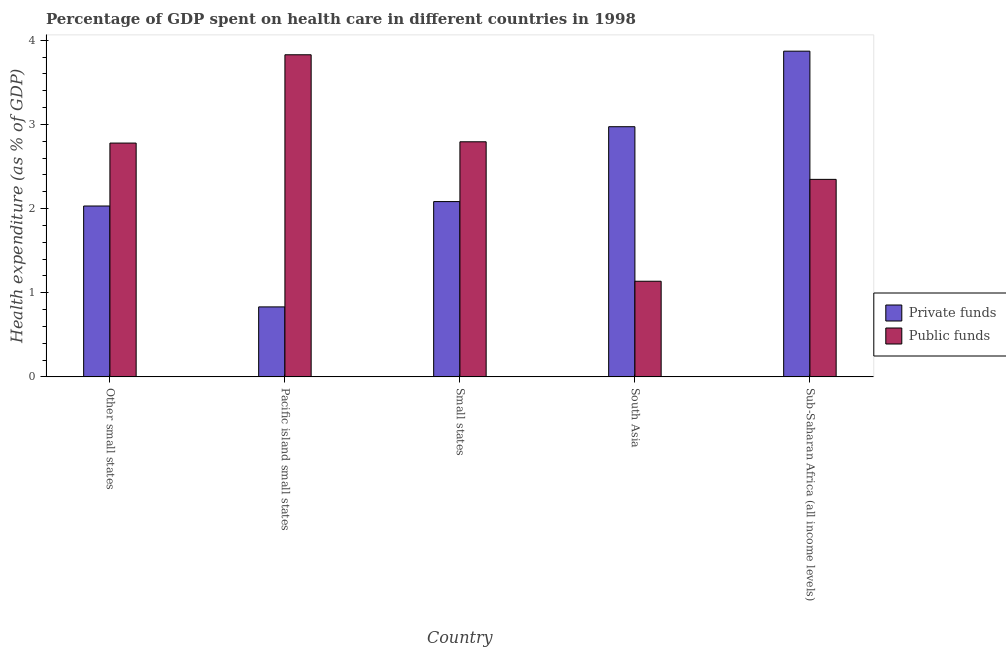How many groups of bars are there?
Provide a succinct answer. 5. Are the number of bars per tick equal to the number of legend labels?
Give a very brief answer. Yes. Are the number of bars on each tick of the X-axis equal?
Ensure brevity in your answer.  Yes. How many bars are there on the 3rd tick from the right?
Your response must be concise. 2. What is the amount of private funds spent in healthcare in South Asia?
Your answer should be compact. 2.97. Across all countries, what is the maximum amount of private funds spent in healthcare?
Offer a terse response. 3.87. Across all countries, what is the minimum amount of private funds spent in healthcare?
Ensure brevity in your answer.  0.83. In which country was the amount of public funds spent in healthcare maximum?
Give a very brief answer. Pacific island small states. In which country was the amount of public funds spent in healthcare minimum?
Offer a terse response. South Asia. What is the total amount of private funds spent in healthcare in the graph?
Make the answer very short. 11.79. What is the difference between the amount of private funds spent in healthcare in Small states and that in Sub-Saharan Africa (all income levels)?
Your response must be concise. -1.79. What is the difference between the amount of public funds spent in healthcare in Pacific island small states and the amount of private funds spent in healthcare in Other small states?
Keep it short and to the point. 1.8. What is the average amount of private funds spent in healthcare per country?
Offer a very short reply. 2.36. What is the difference between the amount of public funds spent in healthcare and amount of private funds spent in healthcare in Pacific island small states?
Offer a very short reply. 3. In how many countries, is the amount of private funds spent in healthcare greater than 3.2 %?
Make the answer very short. 1. What is the ratio of the amount of public funds spent in healthcare in Small states to that in Sub-Saharan Africa (all income levels)?
Provide a succinct answer. 1.19. Is the difference between the amount of public funds spent in healthcare in Other small states and Pacific island small states greater than the difference between the amount of private funds spent in healthcare in Other small states and Pacific island small states?
Offer a very short reply. No. What is the difference between the highest and the second highest amount of private funds spent in healthcare?
Keep it short and to the point. 0.9. What is the difference between the highest and the lowest amount of public funds spent in healthcare?
Make the answer very short. 2.69. Is the sum of the amount of public funds spent in healthcare in South Asia and Sub-Saharan Africa (all income levels) greater than the maximum amount of private funds spent in healthcare across all countries?
Ensure brevity in your answer.  No. What does the 1st bar from the left in South Asia represents?
Keep it short and to the point. Private funds. What does the 2nd bar from the right in Pacific island small states represents?
Ensure brevity in your answer.  Private funds. How many bars are there?
Keep it short and to the point. 10. How many countries are there in the graph?
Make the answer very short. 5. What is the difference between two consecutive major ticks on the Y-axis?
Your answer should be very brief. 1. Does the graph contain any zero values?
Provide a succinct answer. No. Does the graph contain grids?
Provide a succinct answer. No. How many legend labels are there?
Keep it short and to the point. 2. What is the title of the graph?
Offer a very short reply. Percentage of GDP spent on health care in different countries in 1998. Does "Residents" appear as one of the legend labels in the graph?
Ensure brevity in your answer.  No. What is the label or title of the Y-axis?
Offer a terse response. Health expenditure (as % of GDP). What is the Health expenditure (as % of GDP) in Private funds in Other small states?
Make the answer very short. 2.03. What is the Health expenditure (as % of GDP) in Public funds in Other small states?
Provide a short and direct response. 2.78. What is the Health expenditure (as % of GDP) in Private funds in Pacific island small states?
Your response must be concise. 0.83. What is the Health expenditure (as % of GDP) in Public funds in Pacific island small states?
Offer a very short reply. 3.83. What is the Health expenditure (as % of GDP) of Private funds in Small states?
Offer a very short reply. 2.08. What is the Health expenditure (as % of GDP) of Public funds in Small states?
Your answer should be compact. 2.79. What is the Health expenditure (as % of GDP) of Private funds in South Asia?
Make the answer very short. 2.97. What is the Health expenditure (as % of GDP) of Public funds in South Asia?
Offer a very short reply. 1.14. What is the Health expenditure (as % of GDP) of Private funds in Sub-Saharan Africa (all income levels)?
Offer a terse response. 3.87. What is the Health expenditure (as % of GDP) in Public funds in Sub-Saharan Africa (all income levels)?
Offer a very short reply. 2.35. Across all countries, what is the maximum Health expenditure (as % of GDP) of Private funds?
Give a very brief answer. 3.87. Across all countries, what is the maximum Health expenditure (as % of GDP) of Public funds?
Give a very brief answer. 3.83. Across all countries, what is the minimum Health expenditure (as % of GDP) of Private funds?
Provide a short and direct response. 0.83. Across all countries, what is the minimum Health expenditure (as % of GDP) of Public funds?
Your answer should be compact. 1.14. What is the total Health expenditure (as % of GDP) in Private funds in the graph?
Provide a succinct answer. 11.79. What is the total Health expenditure (as % of GDP) in Public funds in the graph?
Offer a very short reply. 12.88. What is the difference between the Health expenditure (as % of GDP) in Private funds in Other small states and that in Pacific island small states?
Offer a very short reply. 1.2. What is the difference between the Health expenditure (as % of GDP) in Public funds in Other small states and that in Pacific island small states?
Offer a very short reply. -1.05. What is the difference between the Health expenditure (as % of GDP) in Private funds in Other small states and that in Small states?
Give a very brief answer. -0.05. What is the difference between the Health expenditure (as % of GDP) in Public funds in Other small states and that in Small states?
Provide a succinct answer. -0.02. What is the difference between the Health expenditure (as % of GDP) of Private funds in Other small states and that in South Asia?
Make the answer very short. -0.94. What is the difference between the Health expenditure (as % of GDP) in Public funds in Other small states and that in South Asia?
Provide a short and direct response. 1.64. What is the difference between the Health expenditure (as % of GDP) of Private funds in Other small states and that in Sub-Saharan Africa (all income levels)?
Provide a succinct answer. -1.84. What is the difference between the Health expenditure (as % of GDP) of Public funds in Other small states and that in Sub-Saharan Africa (all income levels)?
Provide a succinct answer. 0.43. What is the difference between the Health expenditure (as % of GDP) of Private funds in Pacific island small states and that in Small states?
Keep it short and to the point. -1.25. What is the difference between the Health expenditure (as % of GDP) in Public funds in Pacific island small states and that in Small states?
Keep it short and to the point. 1.03. What is the difference between the Health expenditure (as % of GDP) of Private funds in Pacific island small states and that in South Asia?
Offer a very short reply. -2.14. What is the difference between the Health expenditure (as % of GDP) of Public funds in Pacific island small states and that in South Asia?
Offer a very short reply. 2.69. What is the difference between the Health expenditure (as % of GDP) of Private funds in Pacific island small states and that in Sub-Saharan Africa (all income levels)?
Provide a short and direct response. -3.04. What is the difference between the Health expenditure (as % of GDP) of Public funds in Pacific island small states and that in Sub-Saharan Africa (all income levels)?
Ensure brevity in your answer.  1.48. What is the difference between the Health expenditure (as % of GDP) in Private funds in Small states and that in South Asia?
Ensure brevity in your answer.  -0.89. What is the difference between the Health expenditure (as % of GDP) of Public funds in Small states and that in South Asia?
Ensure brevity in your answer.  1.66. What is the difference between the Health expenditure (as % of GDP) in Private funds in Small states and that in Sub-Saharan Africa (all income levels)?
Offer a terse response. -1.79. What is the difference between the Health expenditure (as % of GDP) in Public funds in Small states and that in Sub-Saharan Africa (all income levels)?
Make the answer very short. 0.45. What is the difference between the Health expenditure (as % of GDP) in Private funds in South Asia and that in Sub-Saharan Africa (all income levels)?
Your response must be concise. -0.9. What is the difference between the Health expenditure (as % of GDP) in Public funds in South Asia and that in Sub-Saharan Africa (all income levels)?
Offer a very short reply. -1.21. What is the difference between the Health expenditure (as % of GDP) of Private funds in Other small states and the Health expenditure (as % of GDP) of Public funds in Pacific island small states?
Make the answer very short. -1.8. What is the difference between the Health expenditure (as % of GDP) in Private funds in Other small states and the Health expenditure (as % of GDP) in Public funds in Small states?
Offer a very short reply. -0.76. What is the difference between the Health expenditure (as % of GDP) in Private funds in Other small states and the Health expenditure (as % of GDP) in Public funds in South Asia?
Offer a terse response. 0.89. What is the difference between the Health expenditure (as % of GDP) in Private funds in Other small states and the Health expenditure (as % of GDP) in Public funds in Sub-Saharan Africa (all income levels)?
Provide a short and direct response. -0.32. What is the difference between the Health expenditure (as % of GDP) of Private funds in Pacific island small states and the Health expenditure (as % of GDP) of Public funds in Small states?
Your answer should be very brief. -1.96. What is the difference between the Health expenditure (as % of GDP) of Private funds in Pacific island small states and the Health expenditure (as % of GDP) of Public funds in South Asia?
Your answer should be very brief. -0.3. What is the difference between the Health expenditure (as % of GDP) of Private funds in Pacific island small states and the Health expenditure (as % of GDP) of Public funds in Sub-Saharan Africa (all income levels)?
Keep it short and to the point. -1.52. What is the difference between the Health expenditure (as % of GDP) in Private funds in Small states and the Health expenditure (as % of GDP) in Public funds in South Asia?
Provide a short and direct response. 0.95. What is the difference between the Health expenditure (as % of GDP) in Private funds in Small states and the Health expenditure (as % of GDP) in Public funds in Sub-Saharan Africa (all income levels)?
Provide a succinct answer. -0.26. What is the difference between the Health expenditure (as % of GDP) in Private funds in South Asia and the Health expenditure (as % of GDP) in Public funds in Sub-Saharan Africa (all income levels)?
Offer a very short reply. 0.63. What is the average Health expenditure (as % of GDP) in Private funds per country?
Give a very brief answer. 2.36. What is the average Health expenditure (as % of GDP) in Public funds per country?
Provide a short and direct response. 2.58. What is the difference between the Health expenditure (as % of GDP) of Private funds and Health expenditure (as % of GDP) of Public funds in Other small states?
Offer a terse response. -0.75. What is the difference between the Health expenditure (as % of GDP) of Private funds and Health expenditure (as % of GDP) of Public funds in Pacific island small states?
Keep it short and to the point. -3. What is the difference between the Health expenditure (as % of GDP) in Private funds and Health expenditure (as % of GDP) in Public funds in Small states?
Offer a very short reply. -0.71. What is the difference between the Health expenditure (as % of GDP) of Private funds and Health expenditure (as % of GDP) of Public funds in South Asia?
Your answer should be very brief. 1.84. What is the difference between the Health expenditure (as % of GDP) in Private funds and Health expenditure (as % of GDP) in Public funds in Sub-Saharan Africa (all income levels)?
Provide a succinct answer. 1.52. What is the ratio of the Health expenditure (as % of GDP) of Private funds in Other small states to that in Pacific island small states?
Your answer should be very brief. 2.44. What is the ratio of the Health expenditure (as % of GDP) in Public funds in Other small states to that in Pacific island small states?
Ensure brevity in your answer.  0.73. What is the ratio of the Health expenditure (as % of GDP) in Private funds in Other small states to that in Small states?
Give a very brief answer. 0.97. What is the ratio of the Health expenditure (as % of GDP) of Private funds in Other small states to that in South Asia?
Offer a very short reply. 0.68. What is the ratio of the Health expenditure (as % of GDP) of Public funds in Other small states to that in South Asia?
Make the answer very short. 2.44. What is the ratio of the Health expenditure (as % of GDP) of Private funds in Other small states to that in Sub-Saharan Africa (all income levels)?
Your answer should be very brief. 0.52. What is the ratio of the Health expenditure (as % of GDP) in Public funds in Other small states to that in Sub-Saharan Africa (all income levels)?
Keep it short and to the point. 1.18. What is the ratio of the Health expenditure (as % of GDP) of Private funds in Pacific island small states to that in Small states?
Your response must be concise. 0.4. What is the ratio of the Health expenditure (as % of GDP) in Public funds in Pacific island small states to that in Small states?
Ensure brevity in your answer.  1.37. What is the ratio of the Health expenditure (as % of GDP) in Private funds in Pacific island small states to that in South Asia?
Your answer should be very brief. 0.28. What is the ratio of the Health expenditure (as % of GDP) in Public funds in Pacific island small states to that in South Asia?
Provide a short and direct response. 3.37. What is the ratio of the Health expenditure (as % of GDP) in Private funds in Pacific island small states to that in Sub-Saharan Africa (all income levels)?
Your answer should be compact. 0.21. What is the ratio of the Health expenditure (as % of GDP) in Public funds in Pacific island small states to that in Sub-Saharan Africa (all income levels)?
Offer a terse response. 1.63. What is the ratio of the Health expenditure (as % of GDP) in Private funds in Small states to that in South Asia?
Provide a short and direct response. 0.7. What is the ratio of the Health expenditure (as % of GDP) of Public funds in Small states to that in South Asia?
Your response must be concise. 2.46. What is the ratio of the Health expenditure (as % of GDP) in Private funds in Small states to that in Sub-Saharan Africa (all income levels)?
Your response must be concise. 0.54. What is the ratio of the Health expenditure (as % of GDP) in Public funds in Small states to that in Sub-Saharan Africa (all income levels)?
Your answer should be very brief. 1.19. What is the ratio of the Health expenditure (as % of GDP) in Private funds in South Asia to that in Sub-Saharan Africa (all income levels)?
Give a very brief answer. 0.77. What is the ratio of the Health expenditure (as % of GDP) in Public funds in South Asia to that in Sub-Saharan Africa (all income levels)?
Provide a succinct answer. 0.48. What is the difference between the highest and the second highest Health expenditure (as % of GDP) of Private funds?
Offer a very short reply. 0.9. What is the difference between the highest and the second highest Health expenditure (as % of GDP) of Public funds?
Your response must be concise. 1.03. What is the difference between the highest and the lowest Health expenditure (as % of GDP) of Private funds?
Make the answer very short. 3.04. What is the difference between the highest and the lowest Health expenditure (as % of GDP) of Public funds?
Give a very brief answer. 2.69. 